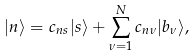Convert formula to latex. <formula><loc_0><loc_0><loc_500><loc_500>| n \rangle = c _ { n s } | s \rangle + \sum _ { \nu = 1 } ^ { N } c _ { n \nu } | b _ { \nu } \rangle ,</formula> 